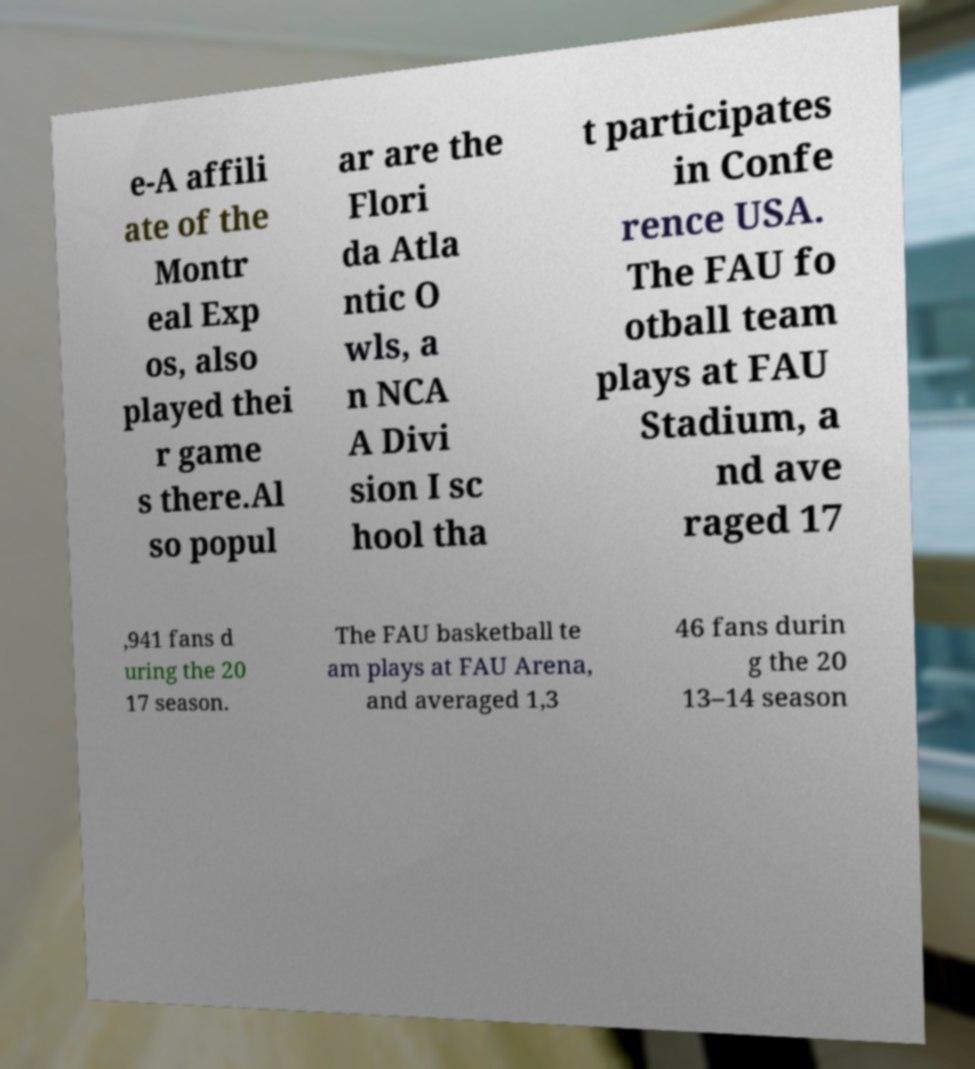Can you read and provide the text displayed in the image?This photo seems to have some interesting text. Can you extract and type it out for me? e-A affili ate of the Montr eal Exp os, also played thei r game s there.Al so popul ar are the Flori da Atla ntic O wls, a n NCA A Divi sion I sc hool tha t participates in Confe rence USA. The FAU fo otball team plays at FAU Stadium, a nd ave raged 17 ,941 fans d uring the 20 17 season. The FAU basketball te am plays at FAU Arena, and averaged 1,3 46 fans durin g the 20 13–14 season 